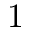Convert formula to latex. <formula><loc_0><loc_0><loc_500><loc_500>1</formula> 